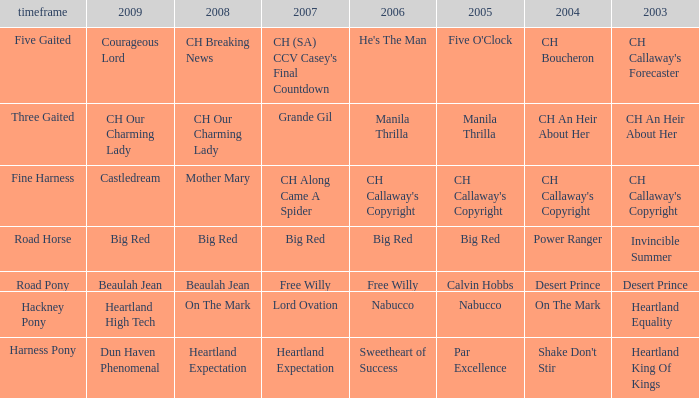What is the 2007 with ch callaway's copyright in 2003? CH Along Came A Spider. 